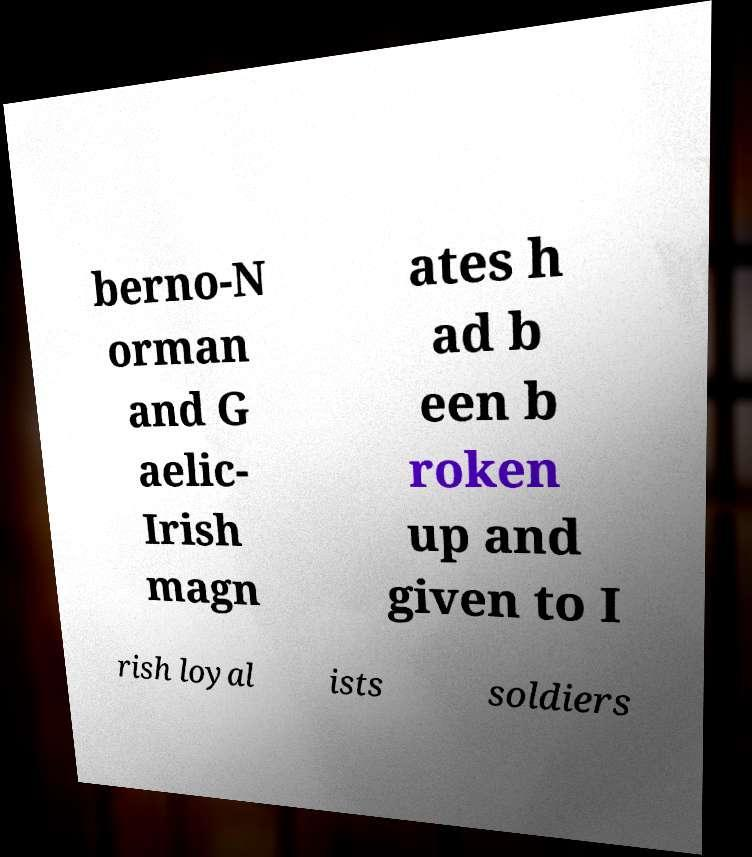For documentation purposes, I need the text within this image transcribed. Could you provide that? berno-N orman and G aelic- Irish magn ates h ad b een b roken up and given to I rish loyal ists soldiers 